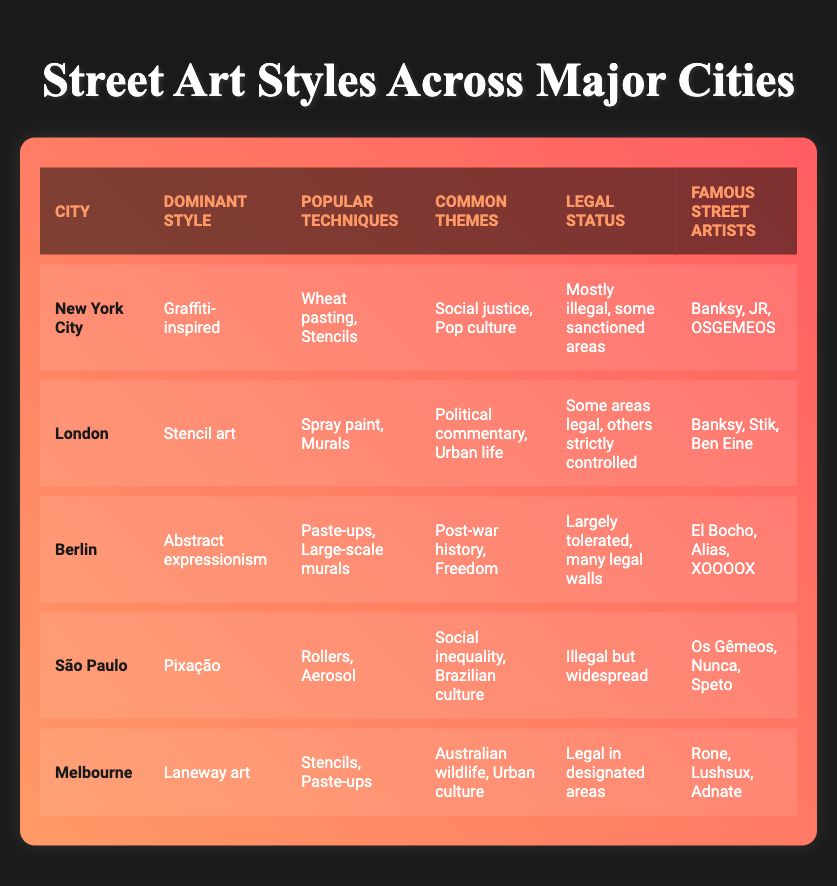What is the dominant street art style in Berlin? The dominant style listed for Berlin in the table is "Abstract expressionism." Therefore, by directly referencing this row's information, we find that this is the answer.
Answer: Abstract expressionism Which city has a legal status that is mostly illegal but has some sanctioned areas? Referring to the legal status column, New York City's legal status is described as "Mostly illegal, some sanctioned areas." Thus, by analyzing the individual city's entry, we confirm this statement.
Answer: New York City What are the common themes of street art in São Paulo? The entry for São Paulo in the table reveals that the common themes include "Social inequality, Brazilian culture." This information is directly obtained from the respective row of the table.
Answer: Social inequality, Brazilian culture How many famous street artists are listed for Melbourne? The table indicates that there are three famous street artists associated with Melbourne: Rone, Lushsux, and Adnate. Counting these entries shows that the answer is three artists.
Answer: Three Is there a city among those listed where street art is legal in designated areas? The table specifies that Melbourne has a legal status described as "Legal in designated areas." Therefore, the answer to whether there is such a city is "Yes."
Answer: Yes Which city has the most famous artists mentioned? From the table, both New York City and London have three famous street artists listed (Banksy, JR, OSGEMEOS for New York City; Banksy, Stik, Ben Eine for London). Since both have the same number, they both qualify. Thus, the answer would need to mention both cities.
Answer: New York City and London What are the popular techniques used in street art in Berlin? By looking at the table, the popular techniques specified for Berlin are "Paste-ups, Large-scale murals." Thus, directly referring to the Berlin entry provides the answer.
Answer: Paste-ups, Large-scale murals Which city's street art themes focus on political commentary and urban life? For London, the table indicates that the common themes are "Political commentary, Urban life." Thus, by checking the common themes for each city, this is affirmed.
Answer: London Are there any cities where the dominant style includes stencil art? The table indicates that London has a dominant style of "Stencil art." Thus, the answer confirms that there is indeed a city with this dominant style.
Answer: Yes 